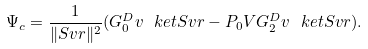Convert formula to latex. <formula><loc_0><loc_0><loc_500><loc_500>\Psi _ { c } = \frac { 1 } { \| S v r \| ^ { 2 } } ( G _ { 0 } ^ { D } v \ k e t { S v r } - P _ { 0 } V G _ { 2 } ^ { D } v \ k e t { S v r } ) .</formula> 